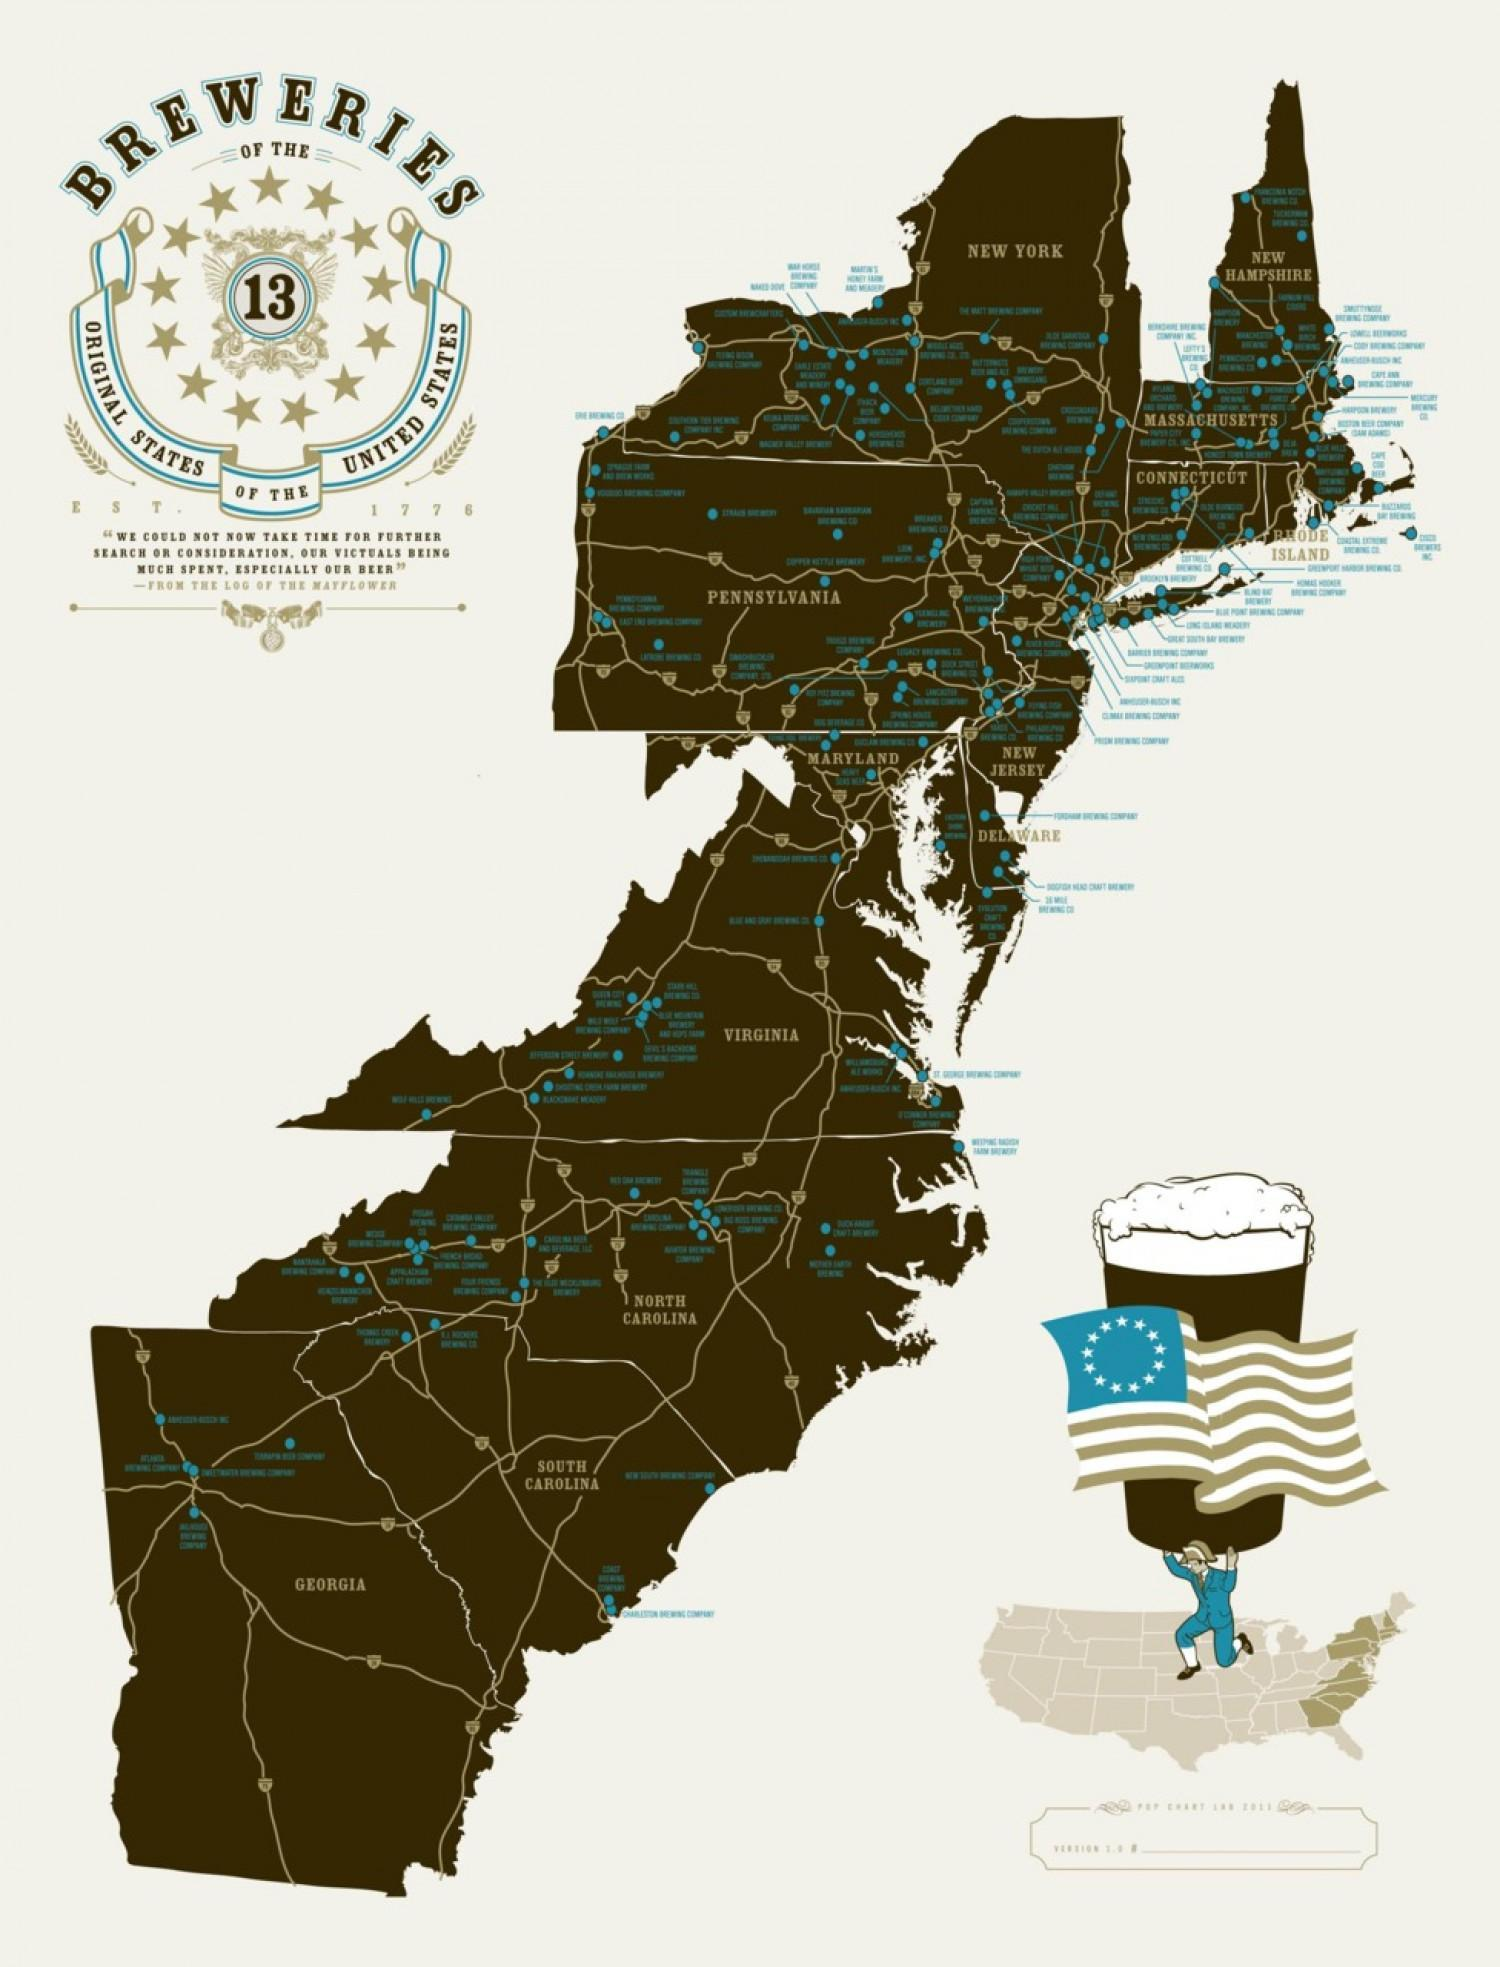How many states are shown in the map ?
Answer the question with a short phrase. 13 